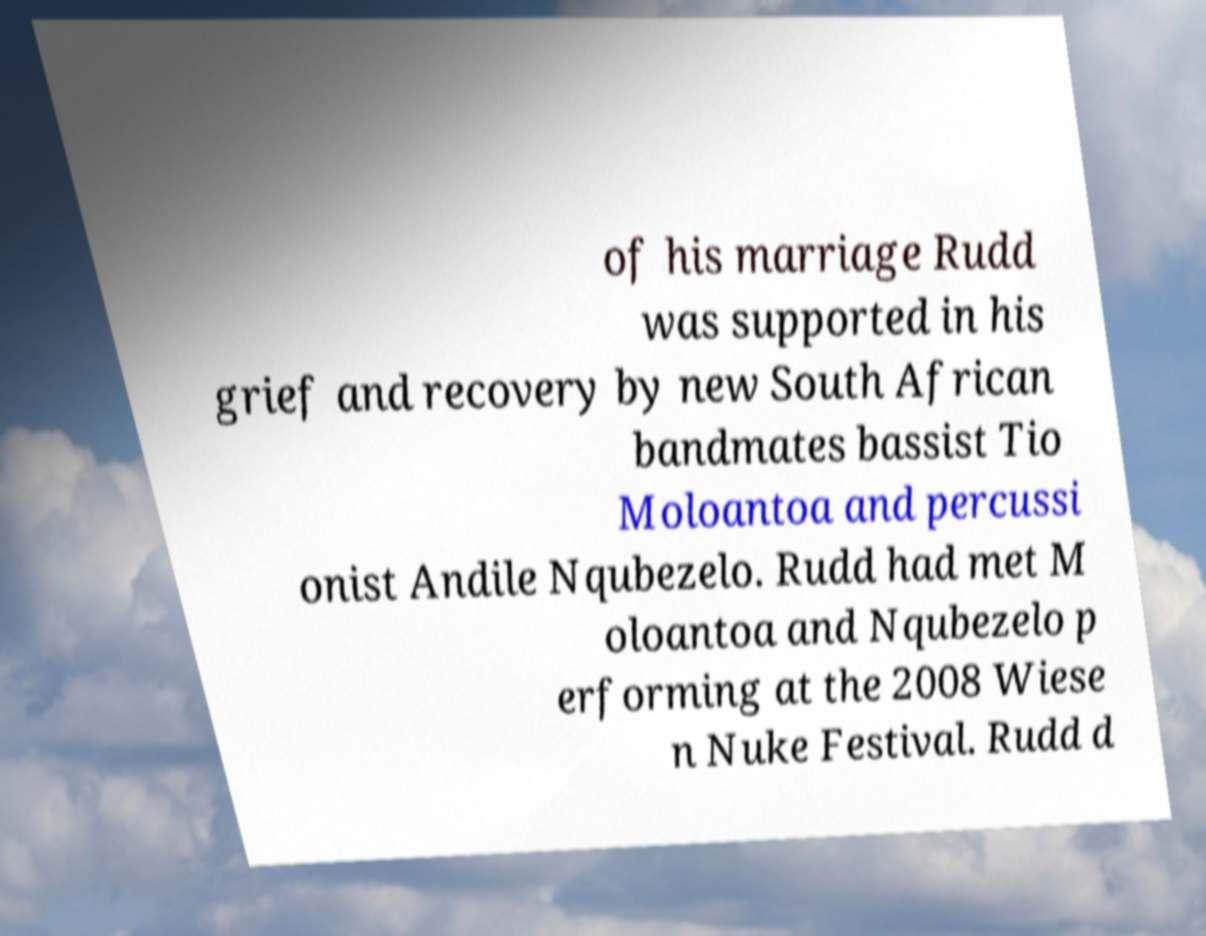I need the written content from this picture converted into text. Can you do that? of his marriage Rudd was supported in his grief and recovery by new South African bandmates bassist Tio Moloantoa and percussi onist Andile Nqubezelo. Rudd had met M oloantoa and Nqubezelo p erforming at the 2008 Wiese n Nuke Festival. Rudd d 